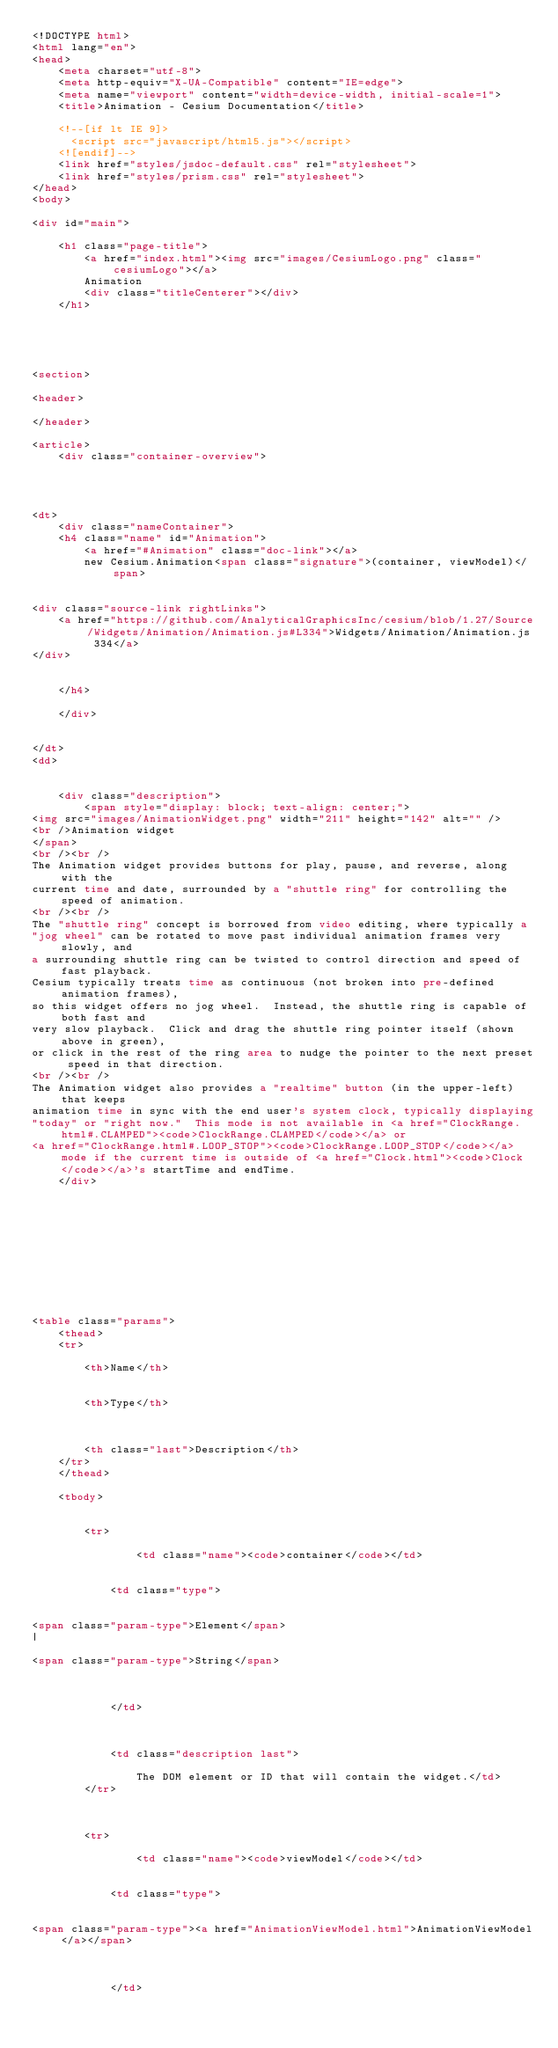<code> <loc_0><loc_0><loc_500><loc_500><_HTML_><!DOCTYPE html>
<html lang="en">
<head>
    <meta charset="utf-8">
    <meta http-equiv="X-UA-Compatible" content="IE=edge">
    <meta name="viewport" content="width=device-width, initial-scale=1">
    <title>Animation - Cesium Documentation</title>

    <!--[if lt IE 9]>
      <script src="javascript/html5.js"></script>
    <![endif]-->
    <link href="styles/jsdoc-default.css" rel="stylesheet">
    <link href="styles/prism.css" rel="stylesheet">
</head>
<body>

<div id="main">

    <h1 class="page-title">
        <a href="index.html"><img src="images/CesiumLogo.png" class="cesiumLogo"></a>
        Animation
        <div class="titleCenterer"></div>
    </h1>

    



<section>

<header>
    
</header>

<article>
    <div class="container-overview">
    

    
        
<dt>
    <div class="nameContainer">
    <h4 class="name" id="Animation">
        <a href="#Animation" class="doc-link"></a>
        new Cesium.Animation<span class="signature">(container, viewModel)</span>
        

<div class="source-link rightLinks">
    <a href="https://github.com/AnalyticalGraphicsInc/cesium/blob/1.27/Source/Widgets/Animation/Animation.js#L334">Widgets/Animation/Animation.js 334</a>
</div>


    </h4>

    </div>

    
</dt>
<dd>

    
    <div class="description">
        <span style="display: block; text-align: center;"><img src="images/AnimationWidget.png" width="211" height="142" alt="" /><br />Animation widget</span><br /><br />The Animation widget provides buttons for play, pause, and reverse, along with thecurrent time and date, surrounded by a "shuttle ring" for controlling the speed of animation.<br /><br />The "shuttle ring" concept is borrowed from video editing, where typically a"jog wheel" can be rotated to move past individual animation frames very slowly, anda surrounding shuttle ring can be twisted to control direction and speed of fast playback.Cesium typically treats time as continuous (not broken into pre-defined animation frames),so this widget offers no jog wheel.  Instead, the shuttle ring is capable of both fast andvery slow playback.  Click and drag the shuttle ring pointer itself (shown above in green),or click in the rest of the ring area to nudge the pointer to the next preset speed in that direction.<br /><br />The Animation widget also provides a "realtime" button (in the upper-left) that keepsanimation time in sync with the end user's system clock, typically displaying"today" or "right now."  This mode is not available in <a href="ClockRange.html#.CLAMPED"><code>ClockRange.CLAMPED</code></a> or<a href="ClockRange.html#.LOOP_STOP"><code>ClockRange.LOOP_STOP</code></a> mode if the current time is outside of <a href="Clock.html"><code>Clock</code></a>'s startTime and endTime.
    </div>
    

    

    

    

    
        

<table class="params">
    <thead>
    <tr>
        
        <th>Name</th>
        

        <th>Type</th>

        

        <th class="last">Description</th>
    </tr>
    </thead>

    <tbody>
    

        <tr>
            
                <td class="name"><code>container</code></td>
            

            <td class="type">
            
                
<span class="param-type">Element</span>
|

<span class="param-type">String</span>


            
            </td>

            

            <td class="description last">
            
                The DOM element or ID that will contain the widget.</td>
        </tr>

    

        <tr>
            
                <td class="name"><code>viewModel</code></td>
            

            <td class="type">
            
                
<span class="param-type"><a href="AnimationViewModel.html">AnimationViewModel</a></span>


            
            </td></code> 